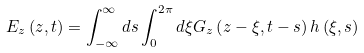<formula> <loc_0><loc_0><loc_500><loc_500>E _ { z } \left ( z , t \right ) = \int _ { - \infty } ^ { \infty } d s \int _ { 0 } ^ { 2 \pi } d \xi G _ { z } \left ( z - \xi , t - s \right ) h \left ( \xi , s \right )</formula> 